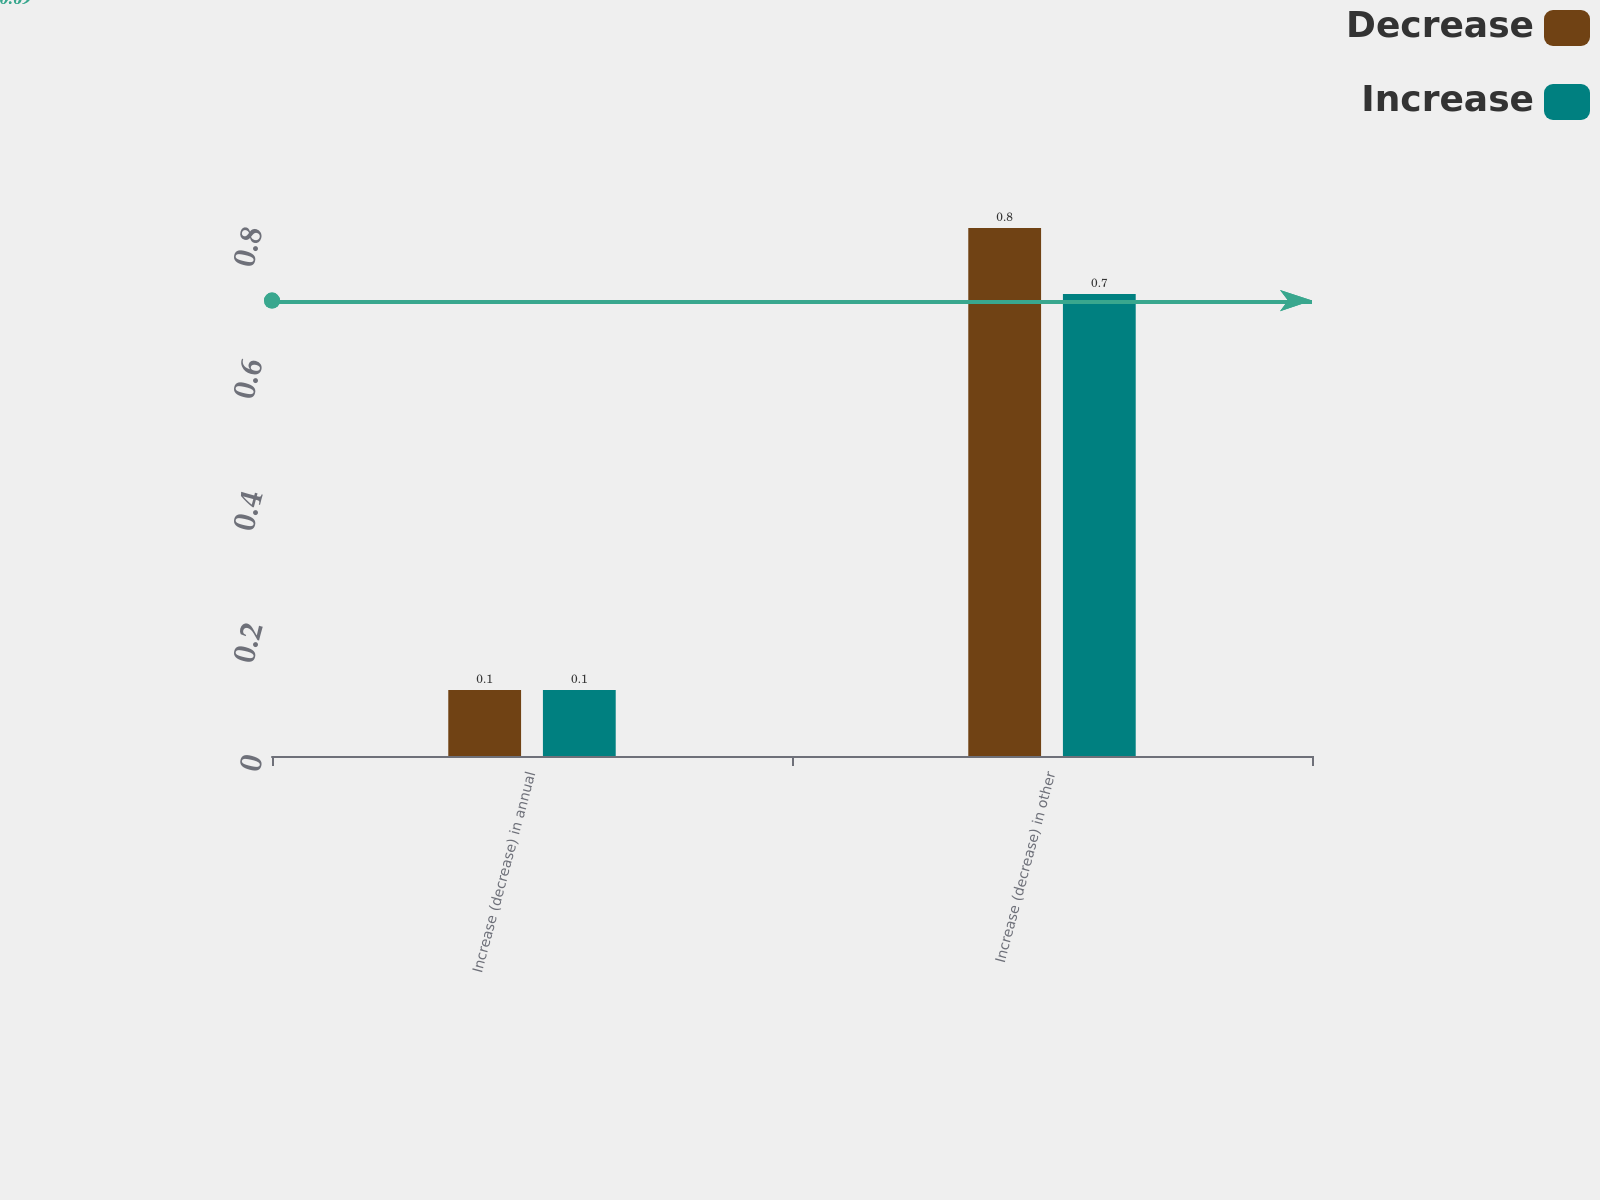<chart> <loc_0><loc_0><loc_500><loc_500><stacked_bar_chart><ecel><fcel>Increase (decrease) in annual<fcel>Increase (decrease) in other<nl><fcel>Decrease<fcel>0.1<fcel>0.8<nl><fcel>Increase<fcel>0.1<fcel>0.7<nl></chart> 